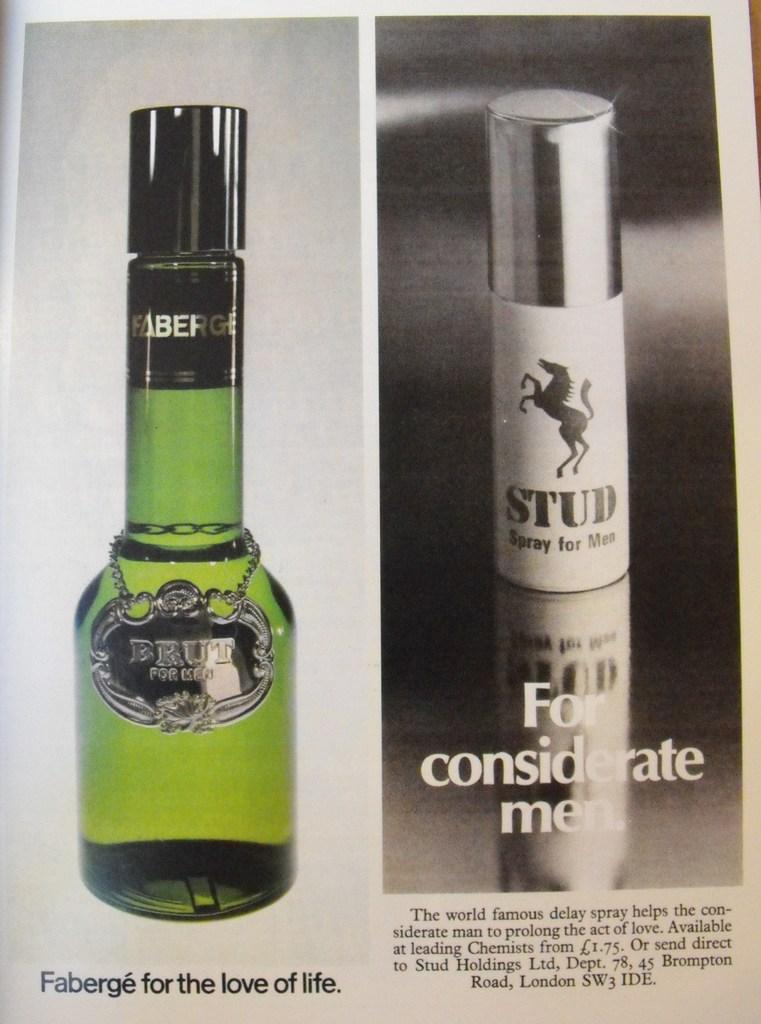<image>
Offer a succinct explanation of the picture presented. An advertisement for Faberge displays Brut for Men and Stud Spray for Men. 